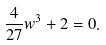<formula> <loc_0><loc_0><loc_500><loc_500>\frac { 4 } { 2 7 } w ^ { 3 } + 2 = 0 .</formula> 